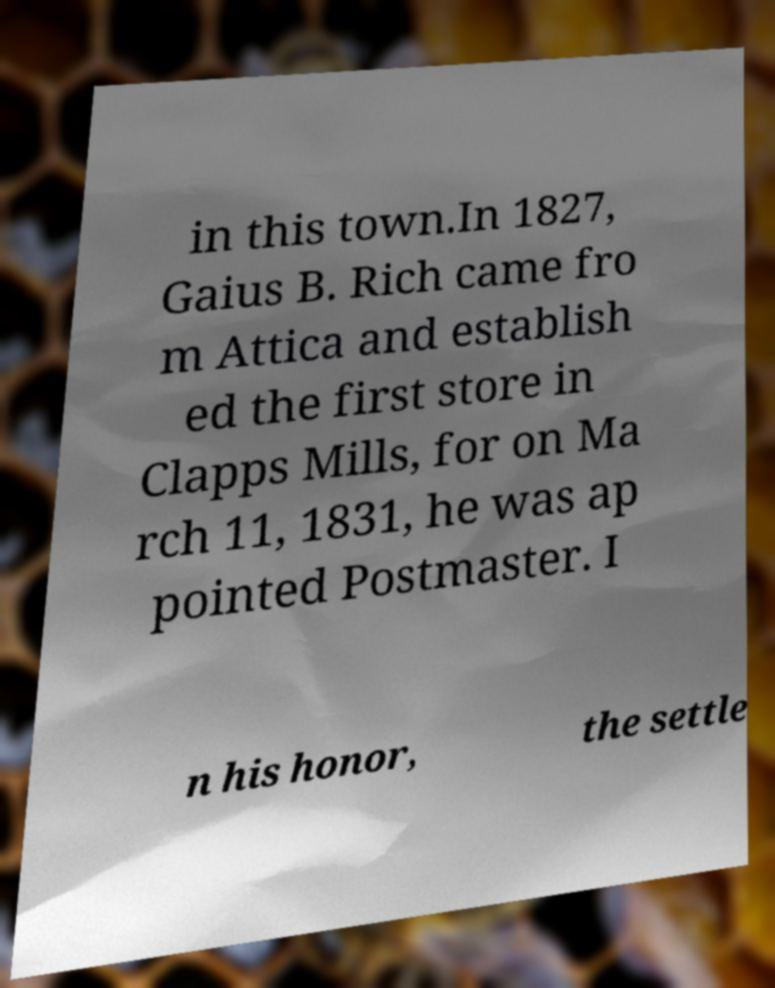Could you extract and type out the text from this image? in this town.In 1827, Gaius B. Rich came fro m Attica and establish ed the first store in Clapps Mills, for on Ma rch 11, 1831, he was ap pointed Postmaster. I n his honor, the settle 